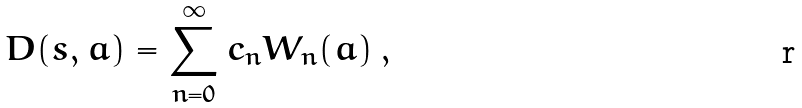Convert formula to latex. <formula><loc_0><loc_0><loc_500><loc_500>D ( s , a ) = \sum _ { n = 0 } ^ { \infty } c _ { n } W _ { n } ( a ) \, ,</formula> 